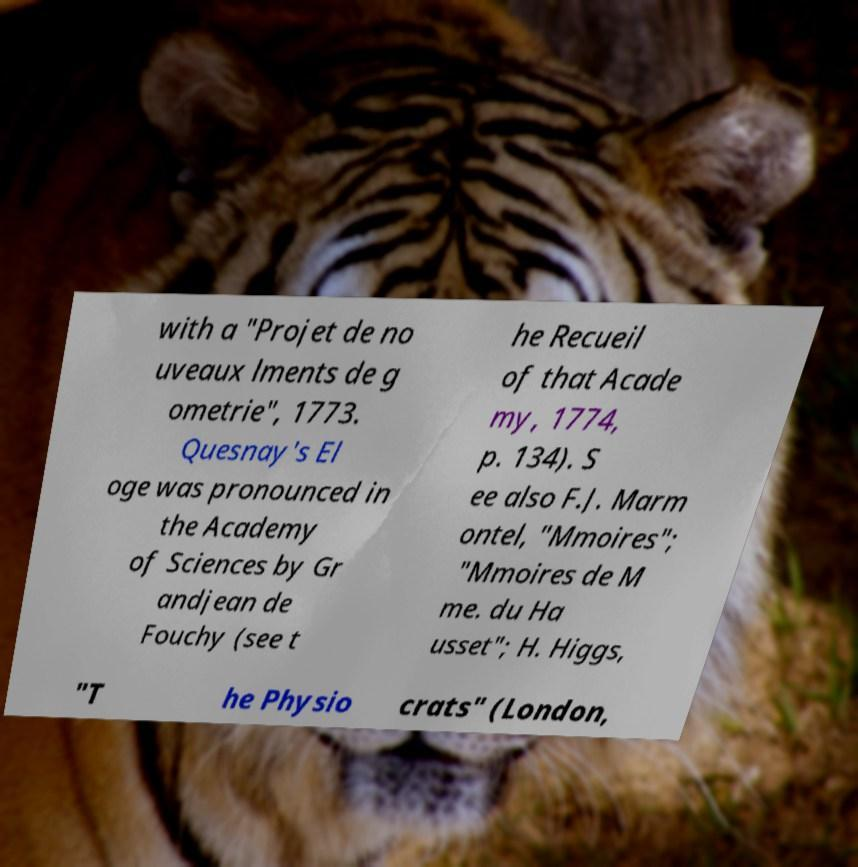There's text embedded in this image that I need extracted. Can you transcribe it verbatim? with a "Projet de no uveaux lments de g ometrie", 1773. Quesnay's El oge was pronounced in the Academy of Sciences by Gr andjean de Fouchy (see t he Recueil of that Acade my, 1774, p. 134). S ee also F.J. Marm ontel, "Mmoires"; "Mmoires de M me. du Ha usset"; H. Higgs, "T he Physio crats" (London, 